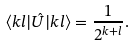Convert formula to latex. <formula><loc_0><loc_0><loc_500><loc_500>\langle k l | \hat { U } | k l \rangle = \frac { 1 } { 2 ^ { k + l } } .</formula> 